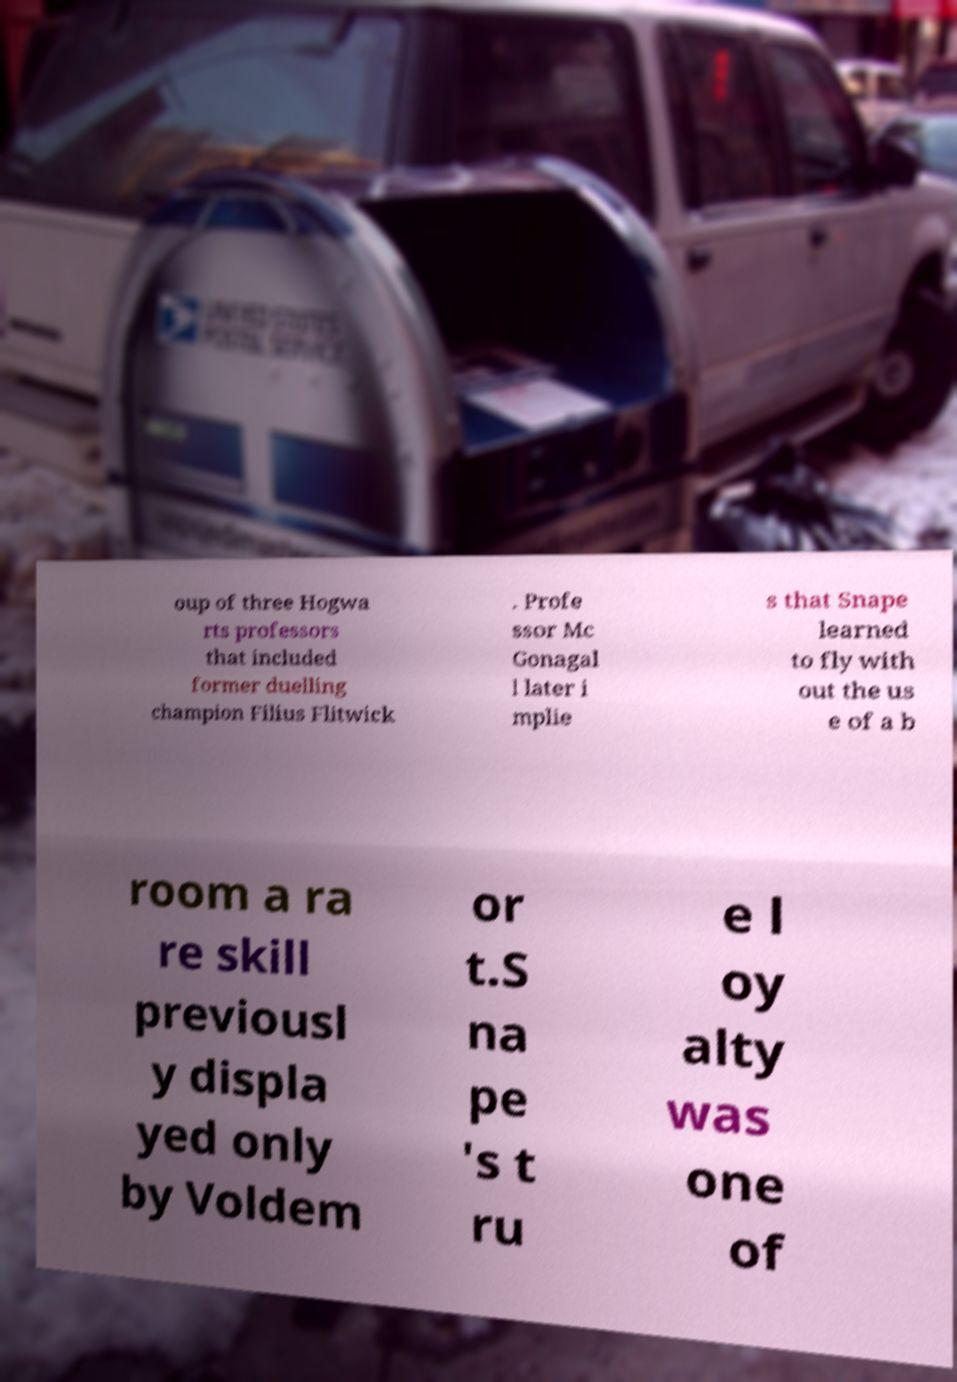Can you read and provide the text displayed in the image?This photo seems to have some interesting text. Can you extract and type it out for me? oup of three Hogwa rts professors that included former duelling champion Filius Flitwick . Profe ssor Mc Gonagal l later i mplie s that Snape learned to fly with out the us e of a b room a ra re skill previousl y displa yed only by Voldem or t.S na pe 's t ru e l oy alty was one of 